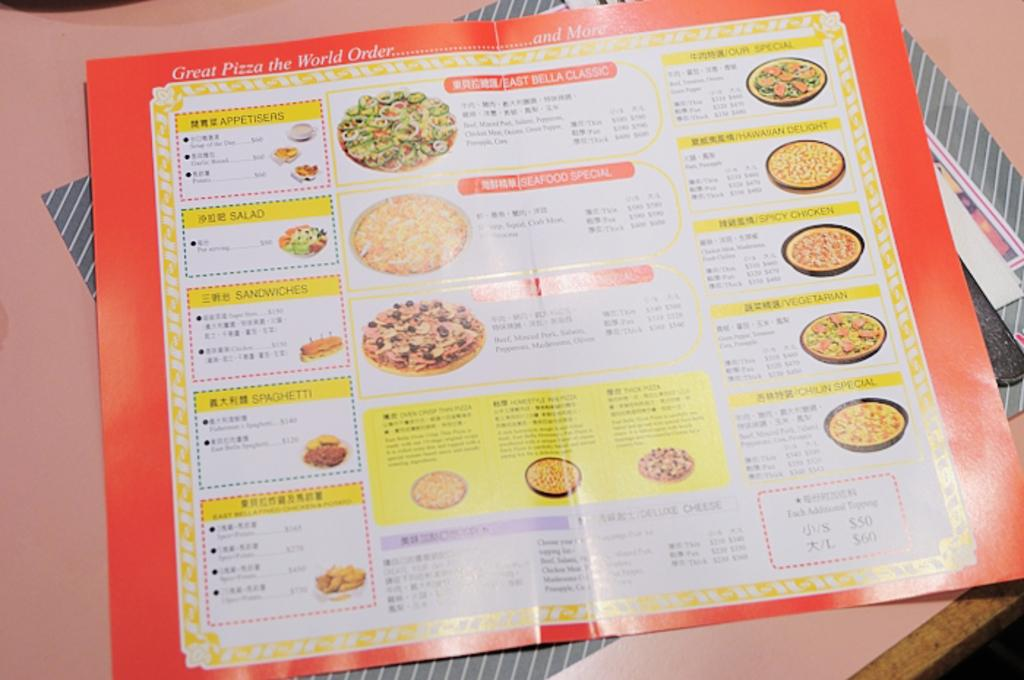What is the main object in the image? There is a menu card in the image. What can be seen on the menu card? The menu card has pictures of food and text on it. Is there anything else on the table in the image? Yes, there is a paper on the table behind the menu card. Can you see a plough in the image? No, there is no plough present in the image. What type of fog can be seen in the image? There is no fog visible in the image. 